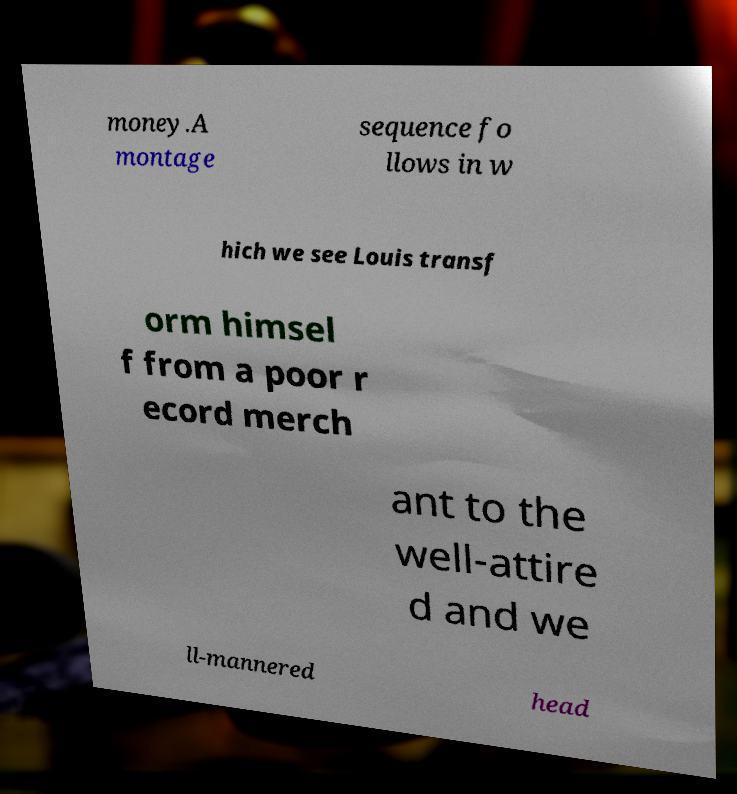Could you assist in decoding the text presented in this image and type it out clearly? money.A montage sequence fo llows in w hich we see Louis transf orm himsel f from a poor r ecord merch ant to the well-attire d and we ll-mannered head 